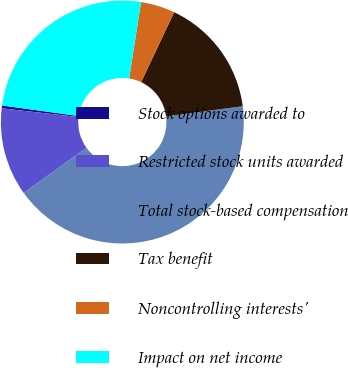Convert chart to OTSL. <chart><loc_0><loc_0><loc_500><loc_500><pie_chart><fcel>Stock options awarded to<fcel>Restricted stock units awarded<fcel>Total stock-based compensation<fcel>Tax benefit<fcel>Noncontrolling interests'<fcel>Impact on net income<nl><fcel>0.37%<fcel>11.73%<fcel>42.16%<fcel>15.91%<fcel>4.55%<fcel>25.29%<nl></chart> 